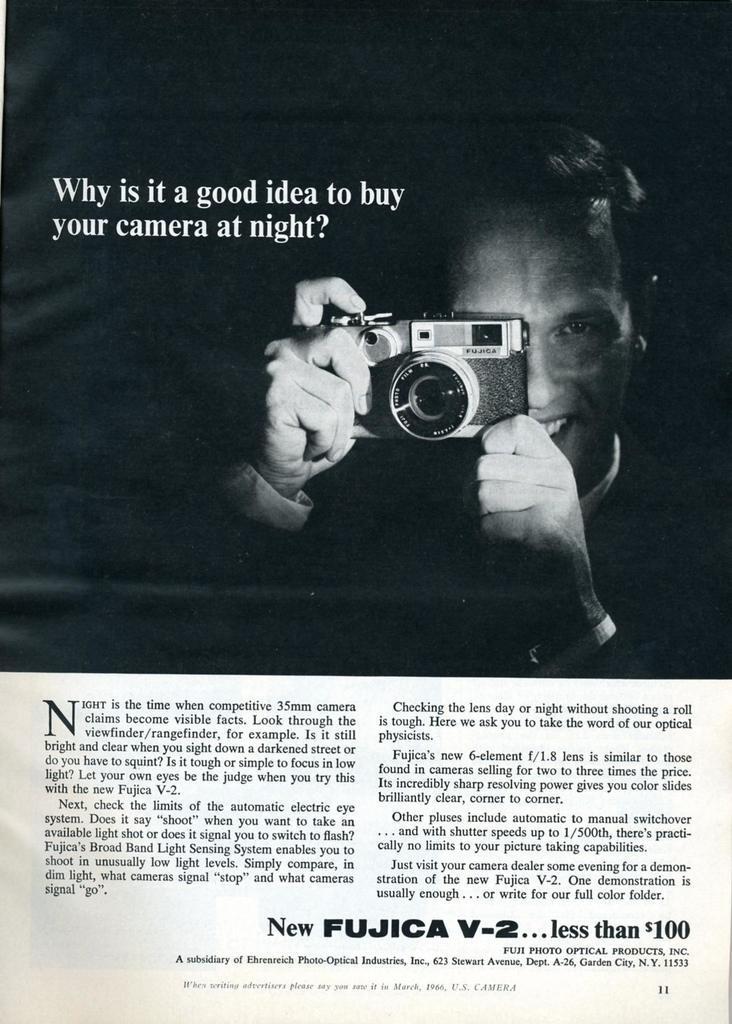In one or two sentences, can you explain what this image depicts? This image is a poster with a text on it. In this image there is a man and he is clicking pictures with a camera. 